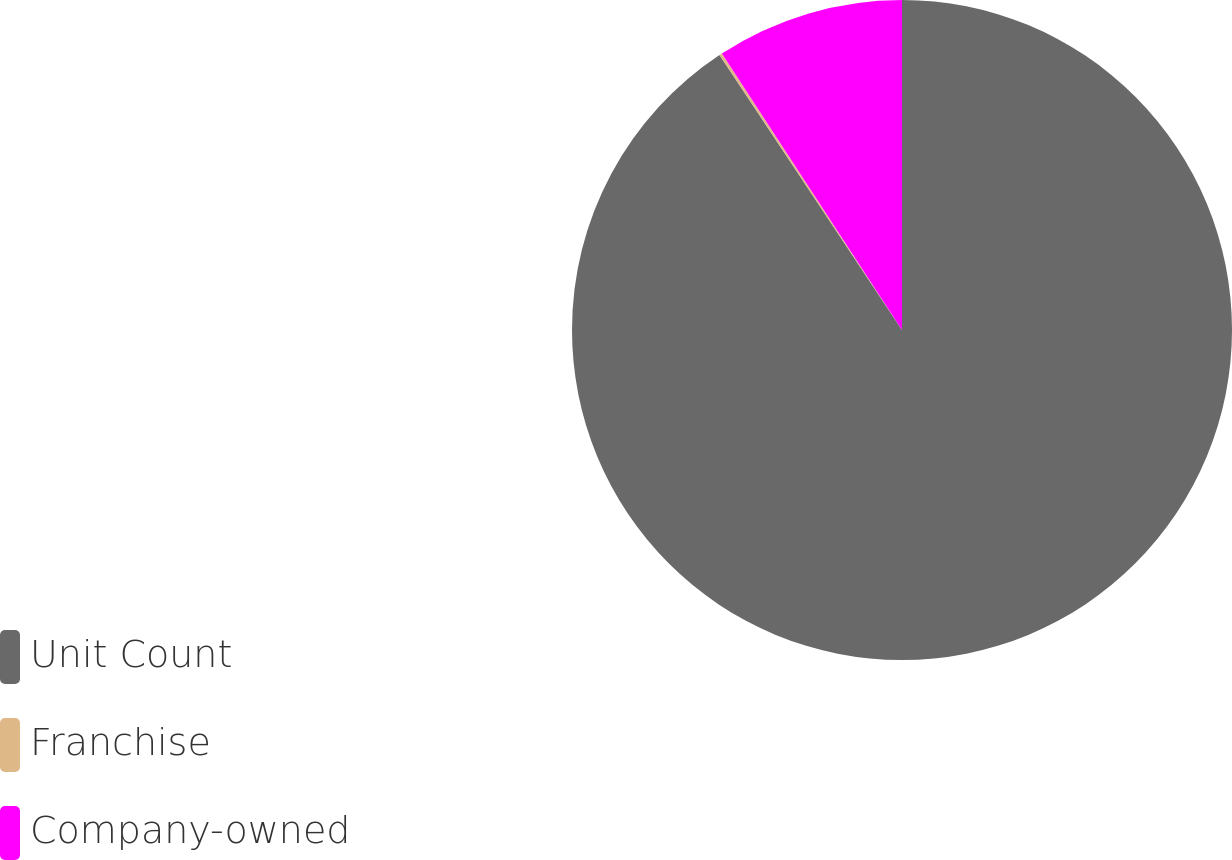Convert chart to OTSL. <chart><loc_0><loc_0><loc_500><loc_500><pie_chart><fcel>Unit Count<fcel>Franchise<fcel>Company-owned<nl><fcel>90.68%<fcel>0.14%<fcel>9.19%<nl></chart> 